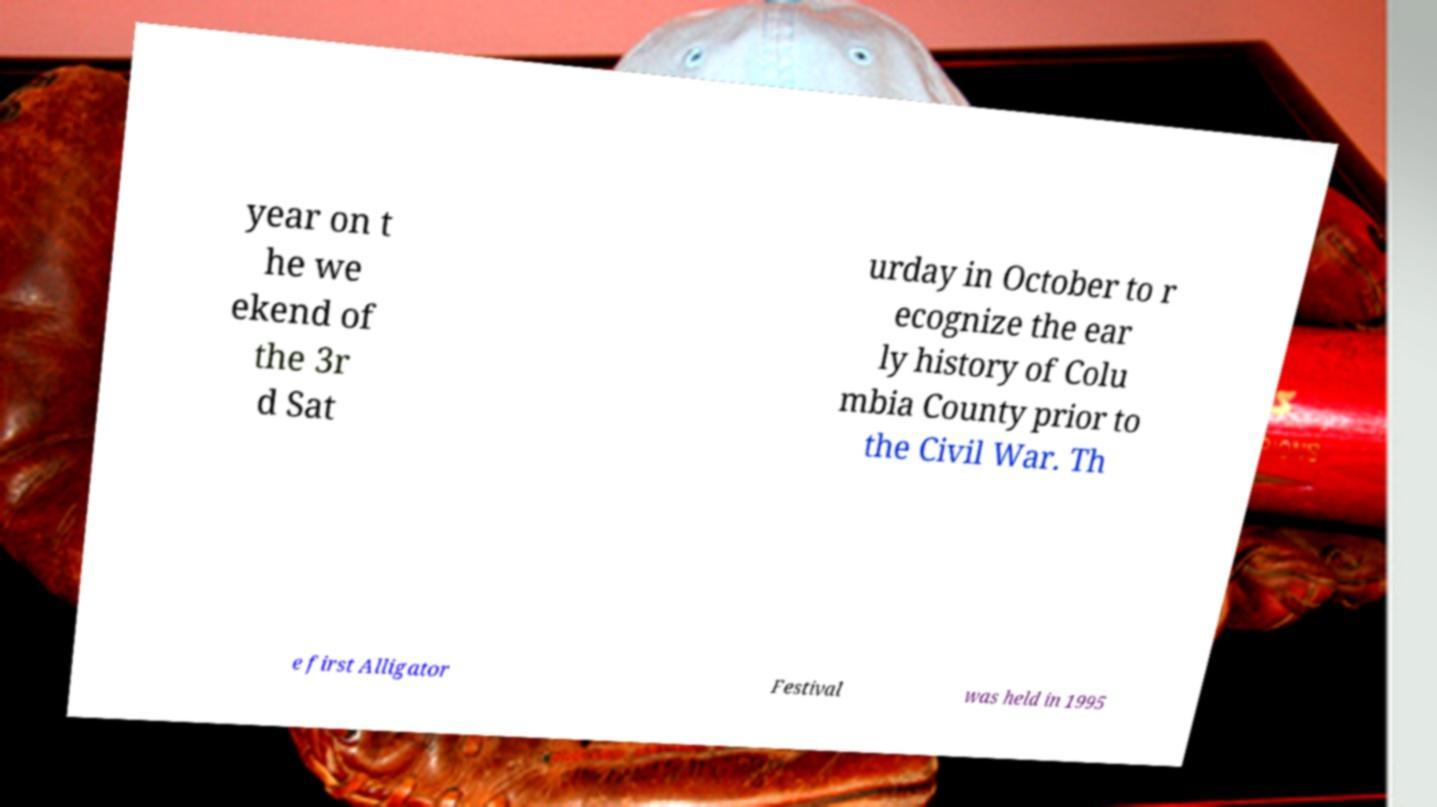Could you extract and type out the text from this image? year on t he we ekend of the 3r d Sat urday in October to r ecognize the ear ly history of Colu mbia County prior to the Civil War. Th e first Alligator Festival was held in 1995 